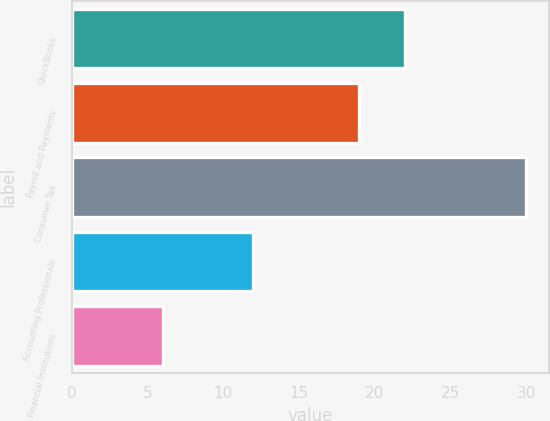Convert chart. <chart><loc_0><loc_0><loc_500><loc_500><bar_chart><fcel>QuickBooks<fcel>Payroll and Payments<fcel>Consumer Tax<fcel>Accounting Professionals<fcel>Financial Institutions<nl><fcel>22<fcel>19<fcel>30<fcel>12<fcel>6<nl></chart> 